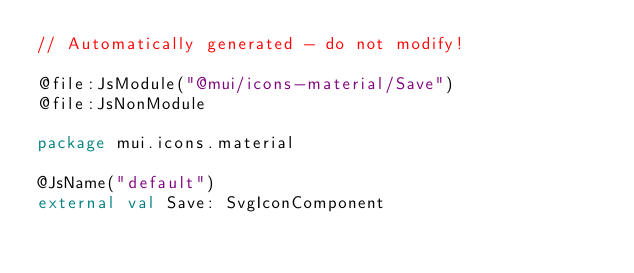<code> <loc_0><loc_0><loc_500><loc_500><_Kotlin_>// Automatically generated - do not modify!

@file:JsModule("@mui/icons-material/Save")
@file:JsNonModule

package mui.icons.material

@JsName("default")
external val Save: SvgIconComponent
</code> 